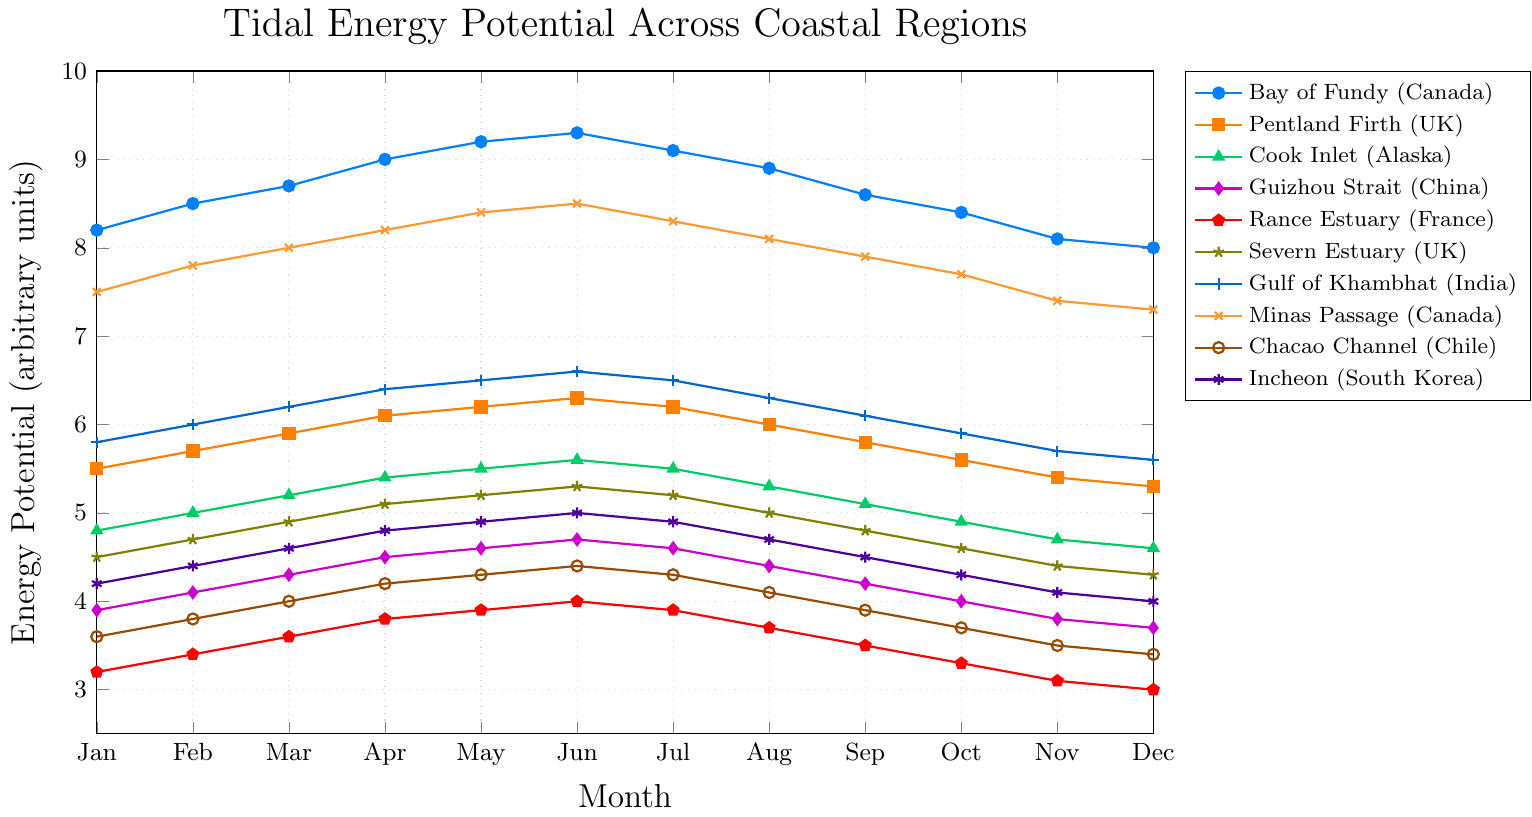Which region has the highest average tidal energy potential over the year? Sum up the monthly tidal energy potentials for each region and divide by 12 (number of months). Bay of Fundy: (8.2 + 8.5 + 8.7 + 9.0 + 9.2 + 9.3 + 9.1 + 8.9 + 8.6 + 8.4 + 8.1 + 8.0) / 12 ≈ 8.66.
Answer: Bay of Fundy (Canada) Between July and August, which region shows the highest decrease in tidal energy potential? Calculate the difference in energy potential between July and August for each region and identify the region with the highest difference. For instance, Bay of Fundy: 9.1 - 8.9 = 0.2. Apply this for all regions.
Answer: Bay of Fundy (Canada) Which region has the steepest increase in tidal energy potential from January to June? For each region, subtract the January value from the June value to measure the increase. The region with the maximum difference will have the steepest increase. For example, Bay of Fundy: 9.3 - 8.2 = 1.1.
Answer: Bay of Fundy (Canada) During May, which region has the lowest tidal energy potential? Identify the energy potential values for May for all regions and select the lowest value. For instance, Rance Estuary has the lowest value: 3.9.
Answer: Rance Estuary (France) What is the average tidal energy potential for the Gulf of Khambhat (India) in the second half of the year? Sum the values from July to December and divide by 6. Gulf of Khambhat: (6.5 + 6.3 + 6.1 + 5.9 + 5.7 + 5.6) / 6 ≈ 6.02.
Answer: 6.02 Which two regions have the closest tidal energy potential in December? Compare the December energy potentials for all regions and find the two with the smallest difference. For instance, Cook Inlet: 4.6 and Severn Estuary: 4.3 have a difference of 0.3, which is one of the smallest.
Answer: Severn Estuary (UK) and Cook Inlet (Alaska) How much does the tidal energy potential of the Chacao Channel (Chile) increase from January to its highest month? Identify the highest potential month and subtract January's value. Chacao Channel's highest is June (4.4), so 4.4 - 3.6 = 0.8.
Answer: 0.8 Which region shows the most variability in tidal energy potential throughout the year? Calculate the range (difference between the highest and lowest monthly values) for each region. The region with the largest range shows the most variability. Bay of Fundy ranges from 8.0 to 9.3, a difference of 1.3, which is the highest.
Answer: Bay of Fundy (Canada) For April, which region has a tidal energy potential closest to the average of all regions for that month? Calculate the average potential for April across all regions, then compare each region's potential to this average. The closest is determined by the minimum difference. Average for April ≈ 6.3. Closest value is Gulf of Khambhat: 6.4.
Answer: Gulf of Khambhat (India) 